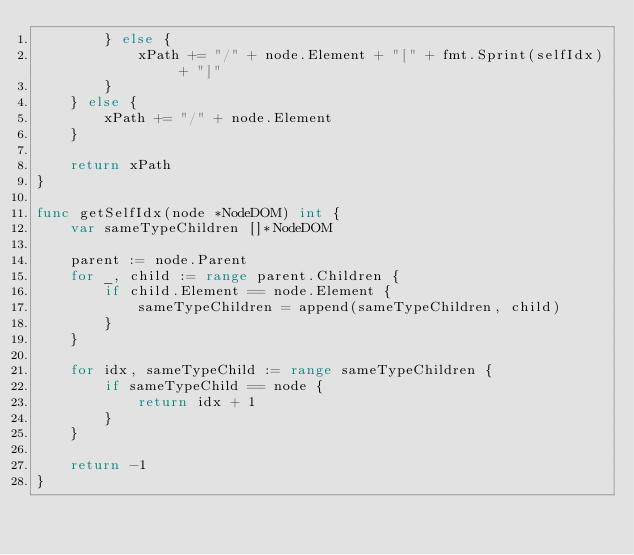Convert code to text. <code><loc_0><loc_0><loc_500><loc_500><_Go_>		} else {
			xPath += "/" + node.Element + "[" + fmt.Sprint(selfIdx) + "]"
		}
	} else {
		xPath += "/" + node.Element
	}

	return xPath
}

func getSelfIdx(node *NodeDOM) int {
	var sameTypeChildren []*NodeDOM

	parent := node.Parent
	for _, child := range parent.Children {
		if child.Element == node.Element {
			sameTypeChildren = append(sameTypeChildren, child)
		}
	}

	for idx, sameTypeChild := range sameTypeChildren {
		if sameTypeChild == node {
			return idx + 1
		}
	}

	return -1
}
</code> 